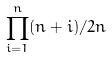<formula> <loc_0><loc_0><loc_500><loc_500>\prod _ { i = 1 } ^ { n } ( n + i ) / 2 n</formula> 